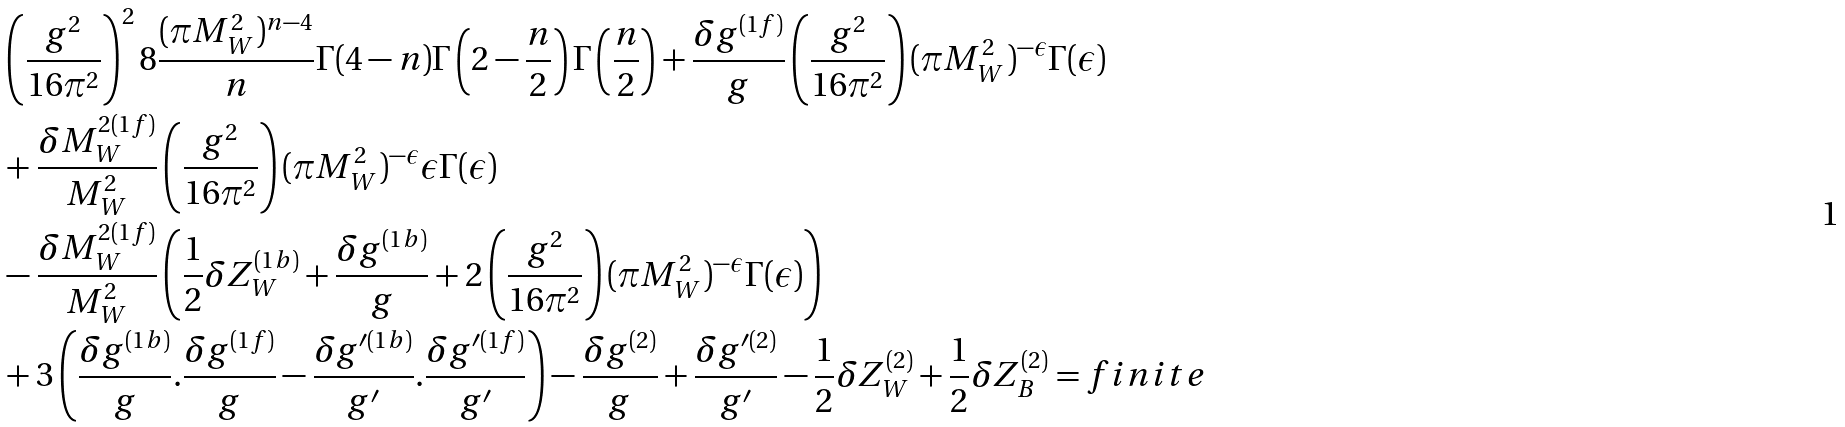<formula> <loc_0><loc_0><loc_500><loc_500>& \left ( \frac { g ^ { 2 } } { 1 6 \pi ^ { 2 } } \right ) ^ { 2 } 8 \frac { ( \pi M _ { W } ^ { 2 } ) ^ { n - 4 } } { n } \Gamma ( 4 - n ) \Gamma \left ( 2 - \frac { n } { 2 } \right ) \Gamma \left ( \frac { n } { 2 } \right ) + \frac { \delta g ^ { ( 1 f ) } } { g } \left ( \frac { g ^ { 2 } } { 1 6 \pi ^ { 2 } } \right ) ( \pi M _ { W } ^ { 2 } ) ^ { - \epsilon } \Gamma ( \epsilon ) \\ & + \frac { \delta M _ { W } ^ { 2 ( 1 f ) } } { M _ { W } ^ { 2 } } \left ( \frac { g ^ { 2 } } { 1 6 \pi ^ { 2 } } \right ) ( \pi M _ { W } ^ { 2 } ) ^ { - \epsilon } \epsilon \Gamma ( \epsilon ) \\ & - \frac { \delta M _ { W } ^ { 2 ( 1 f ) } } { M _ { W } ^ { 2 } } \left ( \frac { 1 } { 2 } \delta Z _ { W } ^ { ( 1 b ) } + \frac { \delta g ^ { ( 1 b ) } } { g } + 2 \left ( \frac { g ^ { 2 } } { 1 6 \pi ^ { 2 } } \right ) ( \pi M _ { W } ^ { 2 } ) ^ { - \epsilon } \Gamma ( \epsilon ) \right ) \\ & + 3 \left ( \frac { \delta g ^ { ( 1 b ) } } { g } . \frac { \delta g ^ { ( 1 f ) } } { g } - \frac { \delta g ^ { \prime ( 1 b ) } } { g ^ { \prime } } . \frac { \delta g ^ { \prime ( 1 f ) } } { g ^ { \prime } } \right ) - \frac { \delta g ^ { ( 2 ) } } { g } + \frac { \delta g ^ { \prime ( 2 ) } } { g ^ { \prime } } - \frac { 1 } { 2 } \delta Z _ { W } ^ { ( 2 ) } + \frac { 1 } { 2 } \delta Z _ { B } ^ { ( 2 ) } = f i n i t e</formula> 